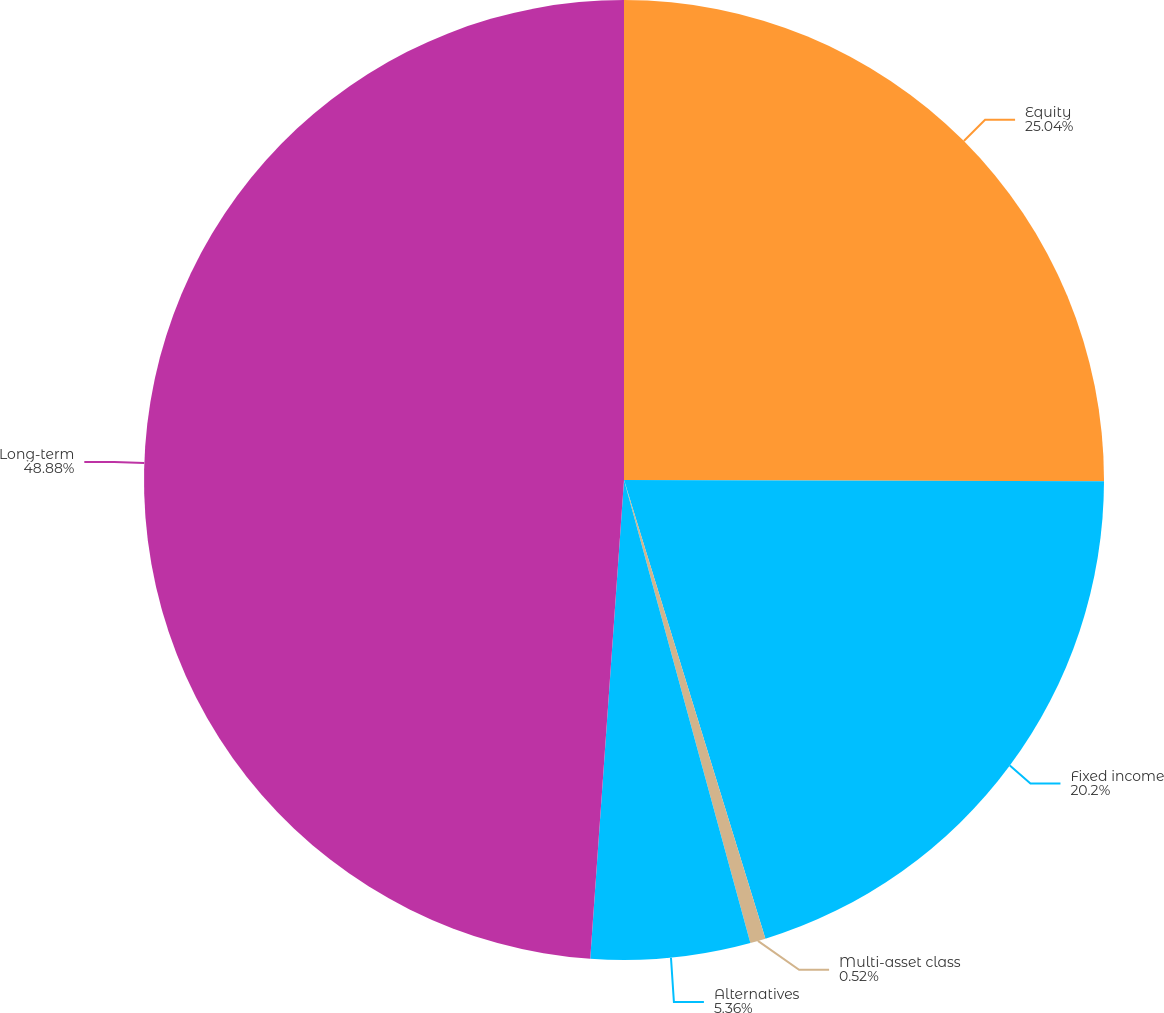Convert chart. <chart><loc_0><loc_0><loc_500><loc_500><pie_chart><fcel>Equity<fcel>Fixed income<fcel>Multi-asset class<fcel>Alternatives<fcel>Long-term<nl><fcel>25.04%<fcel>20.2%<fcel>0.52%<fcel>5.36%<fcel>48.88%<nl></chart> 